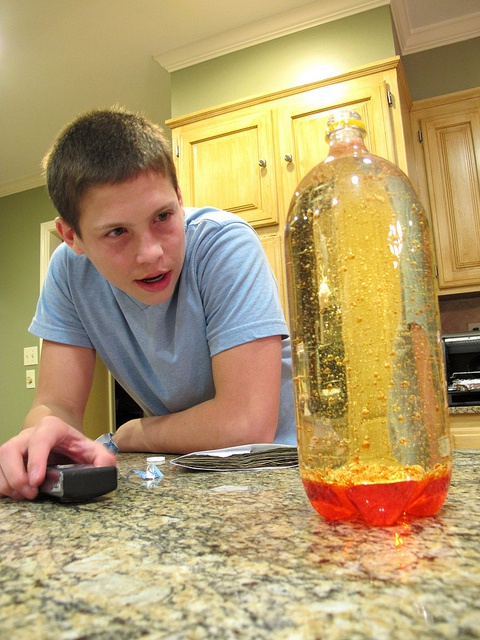Describe the objects in this image and their specific colors. I can see people in tan, salmon, and gray tones, dining table in tan tones, bottle in tan, gold, and orange tones, remote in tan, black, gray, maroon, and darkgray tones, and cell phone in tan, black, gray, maroon, and darkgray tones in this image. 